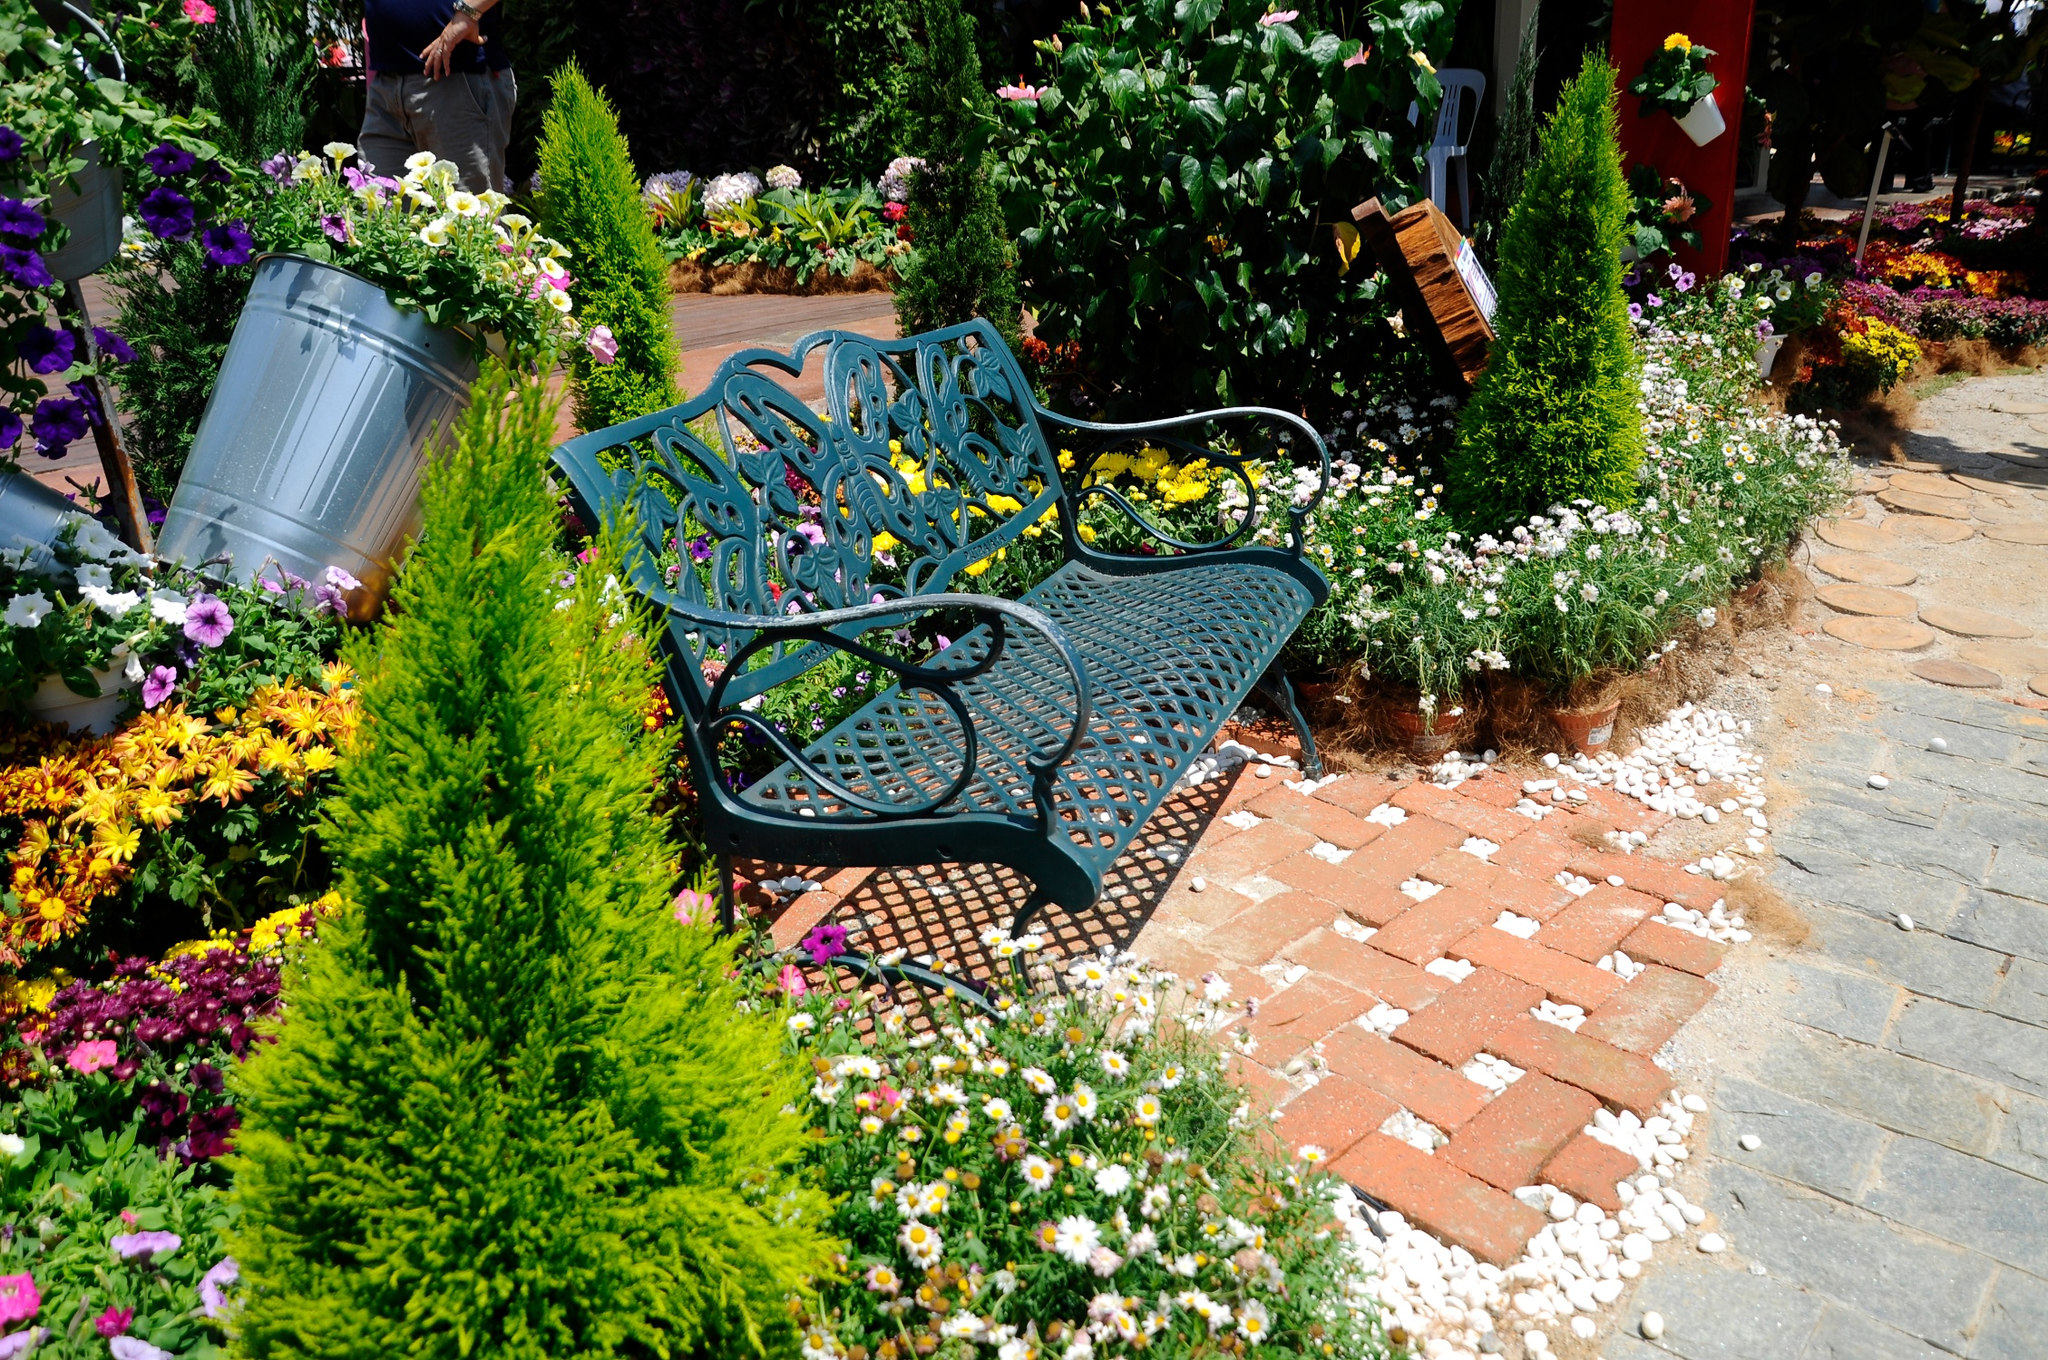Could you create a short poem inspired by this scene? In a garden bright and fair, 
'Neath the sun's tender care, 
A bench of blue with leafy tale, 
Holds secrets in its iron rail. 
Amid blooms of pink and gold, 
Stories of old are softly told, 
Where petals dance in gentle air, 
And time stands still in beauty rare. What kind of fairy tale could unfold in this garden? Once upon a time, in this magical garden, there lived a charming princess named Elara who could communicate with flowers. Each blossom had its own voice, and only Elara could understand their whispered secrets. One day, as Elara sat on the blue bench, the flowers revealed that an evil sorcerer had cast a spell on the nearby kingdom, causing it to wither. The only way to lift the spell was to find the elusive Moonflower that bloomed once every hundred years in a hidden glade. With courage and determination, Elara embarked on a quest, guided by the garden's flowers. Along her journey, she encountered mystical creatures, overcame daunting challenges, and forged alliances with the woodland beings. Finally, with the Moonflower in hand, she returned to the kingdom and broke the sorcerer's curse, restoring life and prosperity. The garden, forever grateful, continued to blossom with extraordinary beauty, symbolizing Elara's bravery and the enduring power of nature's wonders. 